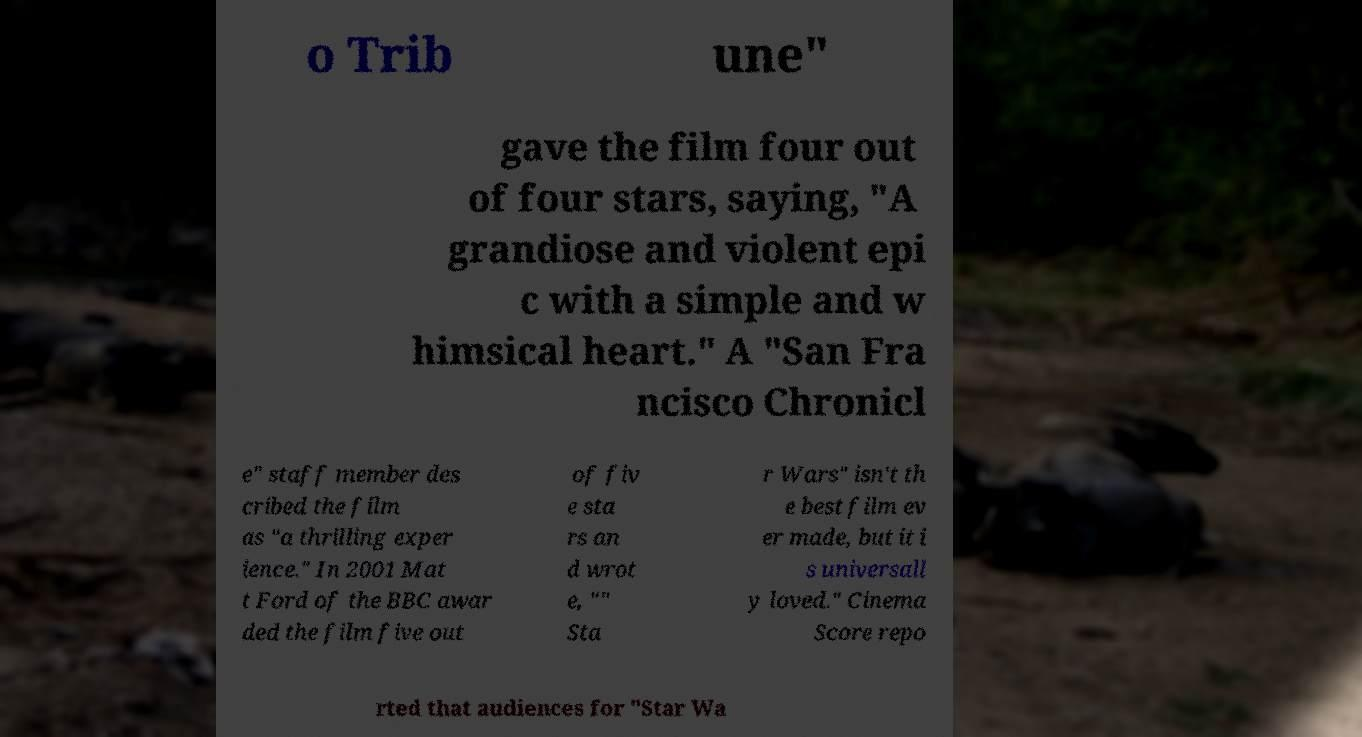Could you assist in decoding the text presented in this image and type it out clearly? o Trib une" gave the film four out of four stars, saying, "A grandiose and violent epi c with a simple and w himsical heart." A "San Fra ncisco Chronicl e" staff member des cribed the film as "a thrilling exper ience." In 2001 Mat t Ford of the BBC awar ded the film five out of fiv e sta rs an d wrot e, "" Sta r Wars" isn't th e best film ev er made, but it i s universall y loved." Cinema Score repo rted that audiences for "Star Wa 